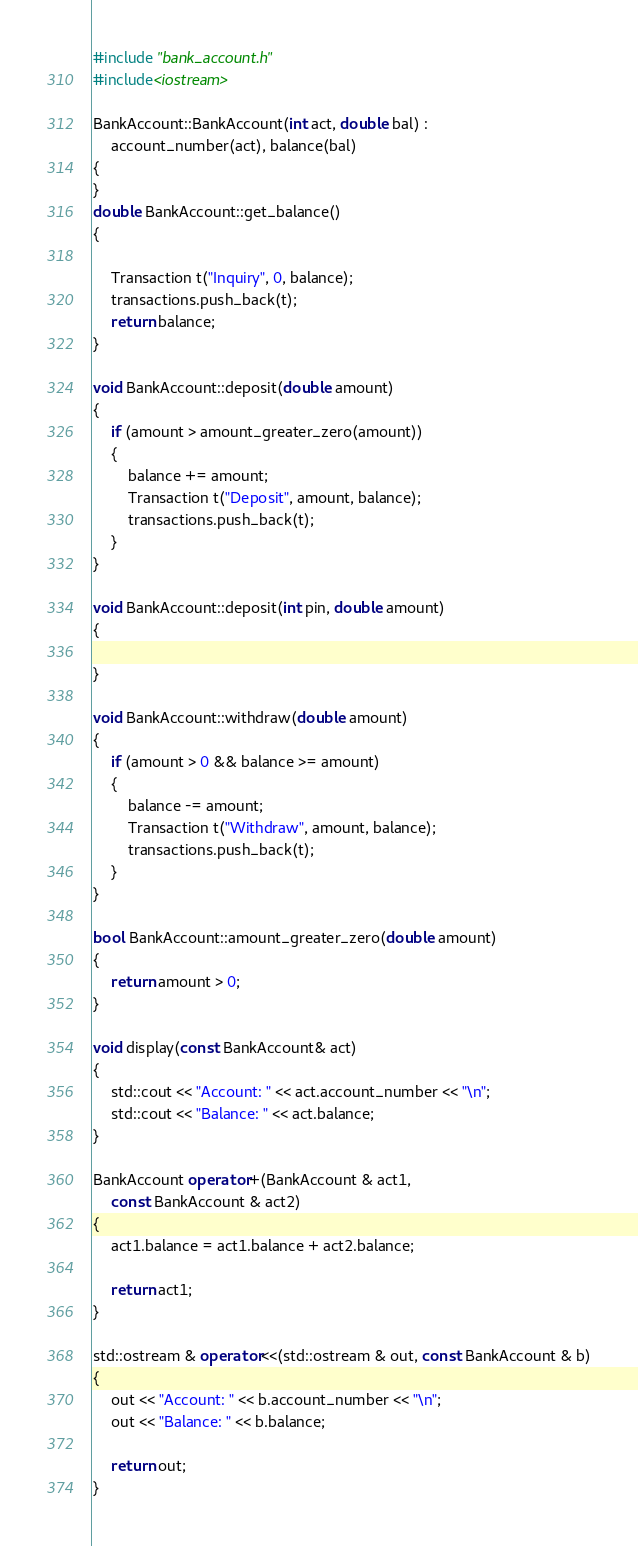Convert code to text. <code><loc_0><loc_0><loc_500><loc_500><_C++_>#include "bank_account.h"
#include<iostream>

BankAccount::BankAccount(int act, double bal) :
	account_number(act), balance(bal)
{
}
double BankAccount::get_balance()
{

	Transaction t("Inquiry", 0, balance);
	transactions.push_back(t);
	return balance;
}

void BankAccount::deposit(double amount)
{
	if (amount > amount_greater_zero(amount))
	{
		balance += amount;
		Transaction t("Deposit", amount, balance);
		transactions.push_back(t);
	}
}

void BankAccount::deposit(int pin, double amount)
{

}

void BankAccount::withdraw(double amount)
{
	if (amount > 0 && balance >= amount)
	{
		balance -= amount;
		Transaction t("Withdraw", amount, balance);
		transactions.push_back(t);
	}
}

bool BankAccount::amount_greater_zero(double amount)
{
	return amount > 0;
}

void display(const BankAccount& act)
{
	std::cout << "Account: " << act.account_number << "\n";
	std::cout << "Balance: " << act.balance;
}

BankAccount operator+(BankAccount & act1,
	const BankAccount & act2)
{
	act1.balance = act1.balance + act2.balance;

	return act1;
}

std::ostream & operator<<(std::ostream & out, const BankAccount & b)
{
	out << "Account: " << b.account_number << "\n";
	out << "Balance: " << b.balance;

	return out;
}</code> 